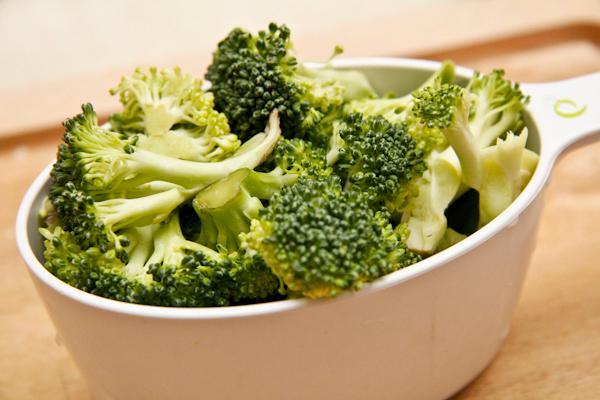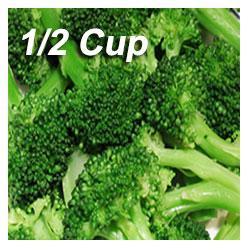The first image is the image on the left, the second image is the image on the right. Evaluate the accuracy of this statement regarding the images: "An image shows broccoli in a round container with one handle.". Is it true? Answer yes or no. Yes. 